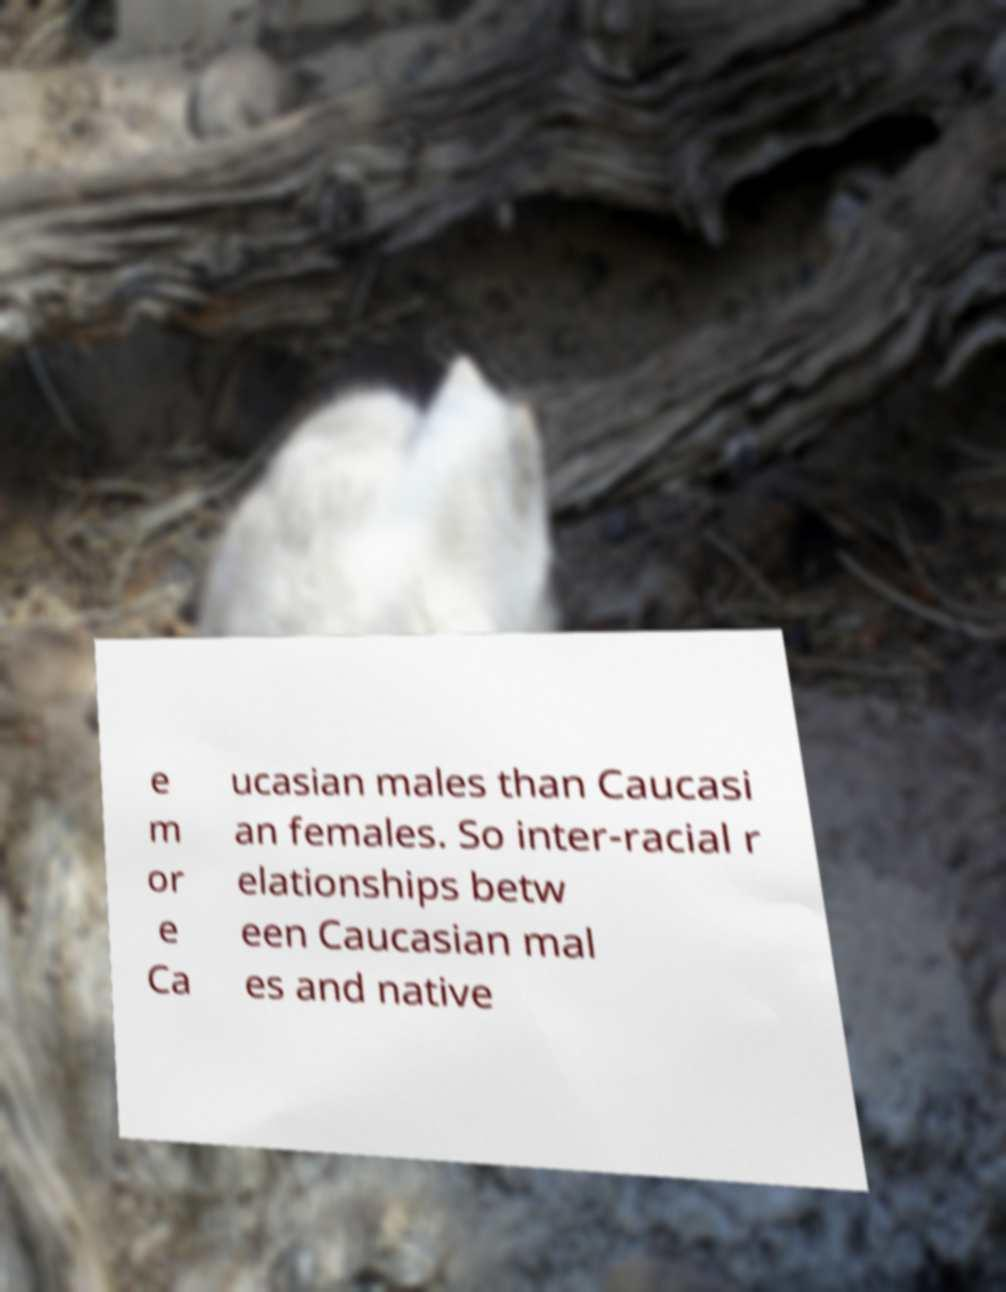Could you assist in decoding the text presented in this image and type it out clearly? e m or e Ca ucasian males than Caucasi an females. So inter-racial r elationships betw een Caucasian mal es and native 